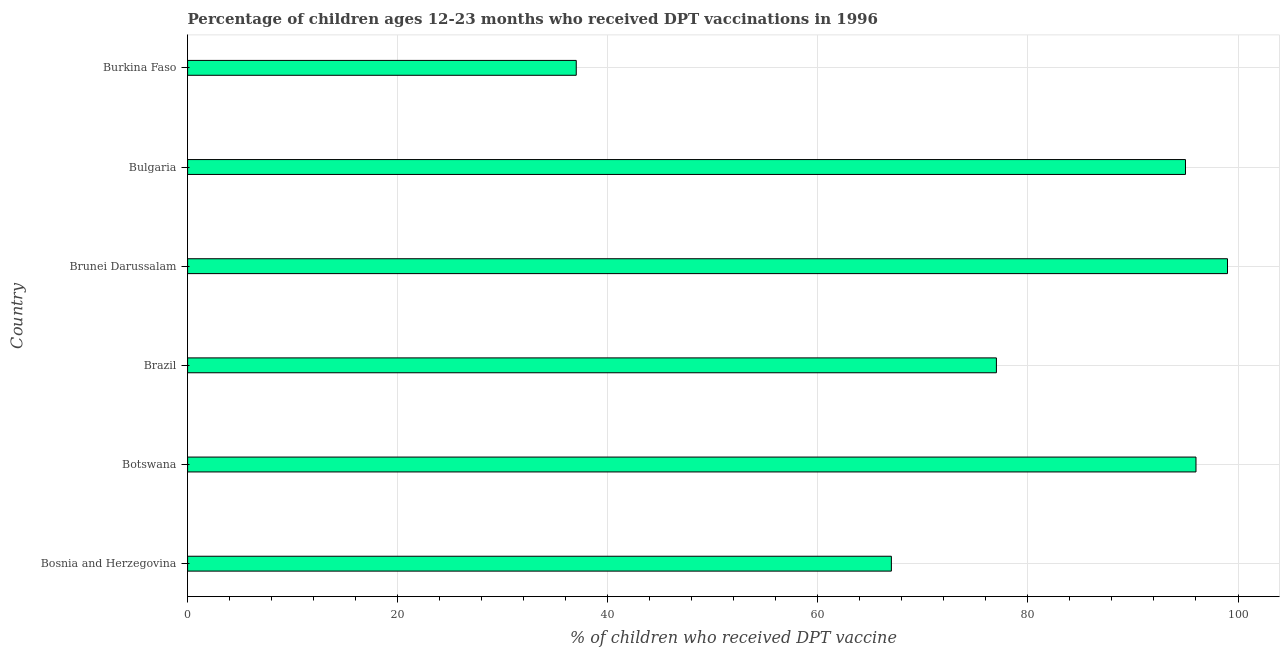Does the graph contain any zero values?
Offer a terse response. No. Does the graph contain grids?
Provide a short and direct response. Yes. What is the title of the graph?
Ensure brevity in your answer.  Percentage of children ages 12-23 months who received DPT vaccinations in 1996. What is the label or title of the X-axis?
Your response must be concise. % of children who received DPT vaccine. What is the percentage of children who received dpt vaccine in Bulgaria?
Your response must be concise. 95. Across all countries, what is the minimum percentage of children who received dpt vaccine?
Give a very brief answer. 37. In which country was the percentage of children who received dpt vaccine maximum?
Make the answer very short. Brunei Darussalam. In which country was the percentage of children who received dpt vaccine minimum?
Make the answer very short. Burkina Faso. What is the sum of the percentage of children who received dpt vaccine?
Your response must be concise. 471. What is the average percentage of children who received dpt vaccine per country?
Ensure brevity in your answer.  78.5. What is the median percentage of children who received dpt vaccine?
Ensure brevity in your answer.  86. Is the percentage of children who received dpt vaccine in Botswana less than that in Burkina Faso?
Provide a succinct answer. No. Is the difference between the percentage of children who received dpt vaccine in Botswana and Brazil greater than the difference between any two countries?
Your answer should be compact. No. What is the difference between the highest and the lowest percentage of children who received dpt vaccine?
Your answer should be very brief. 62. In how many countries, is the percentage of children who received dpt vaccine greater than the average percentage of children who received dpt vaccine taken over all countries?
Your answer should be very brief. 3. How many bars are there?
Make the answer very short. 6. Are all the bars in the graph horizontal?
Make the answer very short. Yes. What is the difference between two consecutive major ticks on the X-axis?
Your answer should be very brief. 20. What is the % of children who received DPT vaccine in Bosnia and Herzegovina?
Ensure brevity in your answer.  67. What is the % of children who received DPT vaccine of Botswana?
Offer a very short reply. 96. What is the % of children who received DPT vaccine of Brazil?
Give a very brief answer. 77. What is the % of children who received DPT vaccine in Brunei Darussalam?
Your answer should be compact. 99. What is the % of children who received DPT vaccine in Bulgaria?
Offer a very short reply. 95. What is the difference between the % of children who received DPT vaccine in Bosnia and Herzegovina and Botswana?
Your answer should be compact. -29. What is the difference between the % of children who received DPT vaccine in Bosnia and Herzegovina and Brunei Darussalam?
Make the answer very short. -32. What is the difference between the % of children who received DPT vaccine in Bosnia and Herzegovina and Bulgaria?
Your answer should be very brief. -28. What is the difference between the % of children who received DPT vaccine in Botswana and Brazil?
Offer a terse response. 19. What is the difference between the % of children who received DPT vaccine in Botswana and Burkina Faso?
Ensure brevity in your answer.  59. What is the difference between the % of children who received DPT vaccine in Brazil and Burkina Faso?
Your answer should be very brief. 40. What is the difference between the % of children who received DPT vaccine in Brunei Darussalam and Bulgaria?
Keep it short and to the point. 4. What is the difference between the % of children who received DPT vaccine in Bulgaria and Burkina Faso?
Give a very brief answer. 58. What is the ratio of the % of children who received DPT vaccine in Bosnia and Herzegovina to that in Botswana?
Provide a short and direct response. 0.7. What is the ratio of the % of children who received DPT vaccine in Bosnia and Herzegovina to that in Brazil?
Your answer should be compact. 0.87. What is the ratio of the % of children who received DPT vaccine in Bosnia and Herzegovina to that in Brunei Darussalam?
Keep it short and to the point. 0.68. What is the ratio of the % of children who received DPT vaccine in Bosnia and Herzegovina to that in Bulgaria?
Keep it short and to the point. 0.7. What is the ratio of the % of children who received DPT vaccine in Bosnia and Herzegovina to that in Burkina Faso?
Your response must be concise. 1.81. What is the ratio of the % of children who received DPT vaccine in Botswana to that in Brazil?
Your answer should be very brief. 1.25. What is the ratio of the % of children who received DPT vaccine in Botswana to that in Burkina Faso?
Provide a succinct answer. 2.6. What is the ratio of the % of children who received DPT vaccine in Brazil to that in Brunei Darussalam?
Your answer should be very brief. 0.78. What is the ratio of the % of children who received DPT vaccine in Brazil to that in Bulgaria?
Provide a succinct answer. 0.81. What is the ratio of the % of children who received DPT vaccine in Brazil to that in Burkina Faso?
Offer a terse response. 2.08. What is the ratio of the % of children who received DPT vaccine in Brunei Darussalam to that in Bulgaria?
Offer a very short reply. 1.04. What is the ratio of the % of children who received DPT vaccine in Brunei Darussalam to that in Burkina Faso?
Give a very brief answer. 2.68. What is the ratio of the % of children who received DPT vaccine in Bulgaria to that in Burkina Faso?
Provide a succinct answer. 2.57. 